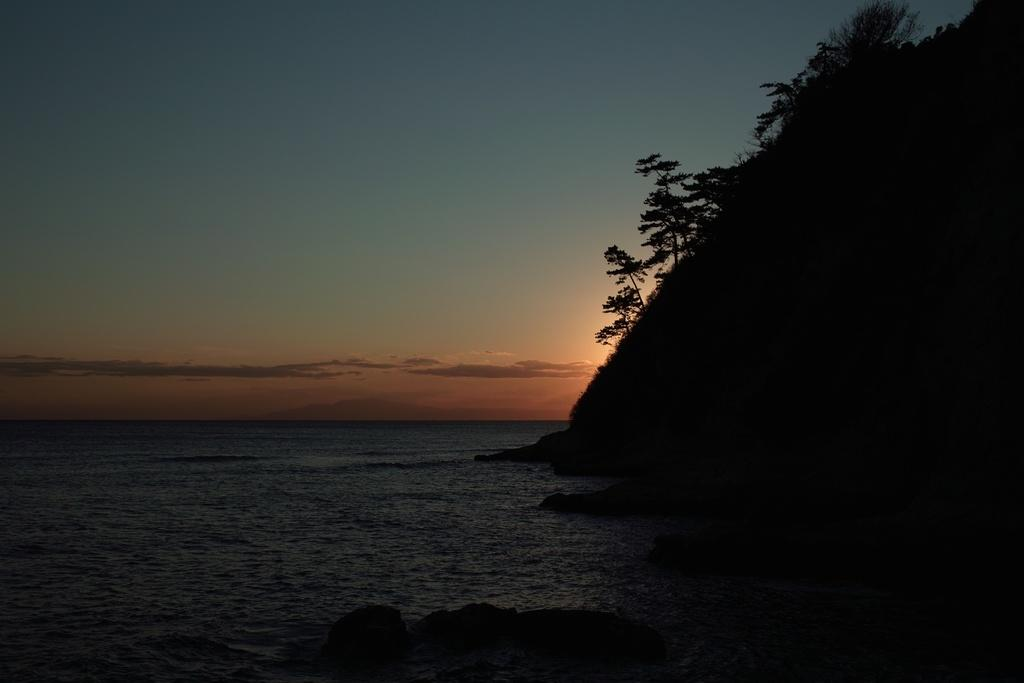What type of landscape is depicted in the image? The image features trees on a hill and a large water body. What can be seen in the background of the image? The sky is visible in the image. How would you describe the weather based on the appearance of the sky? The sky appears to be cloudy in the image. How many apples are hanging from the trees in the image? There are no apples visible in the image; it features trees on a hill without any fruit. What color is the shirt worn by the tree in the image? Trees do not wear shirts, so this question cannot be answered based on the image. 